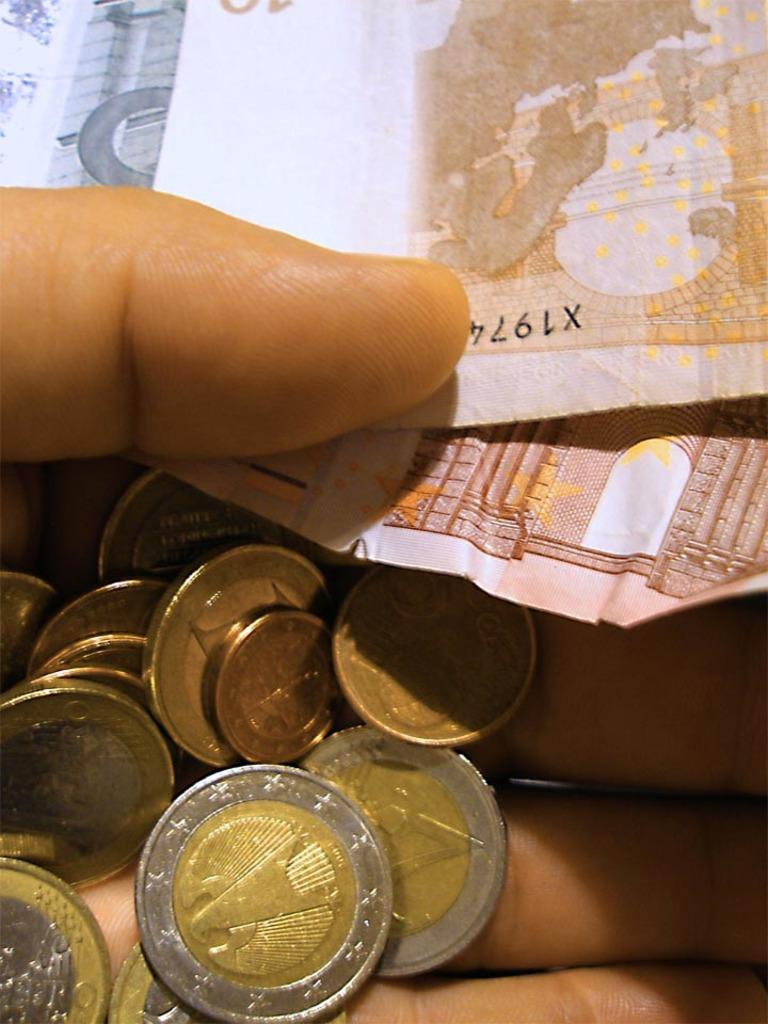<image>
Share a concise interpretation of the image provided. A hand holds a variety of coins and some bills, one with a partial serial number of X1974. 